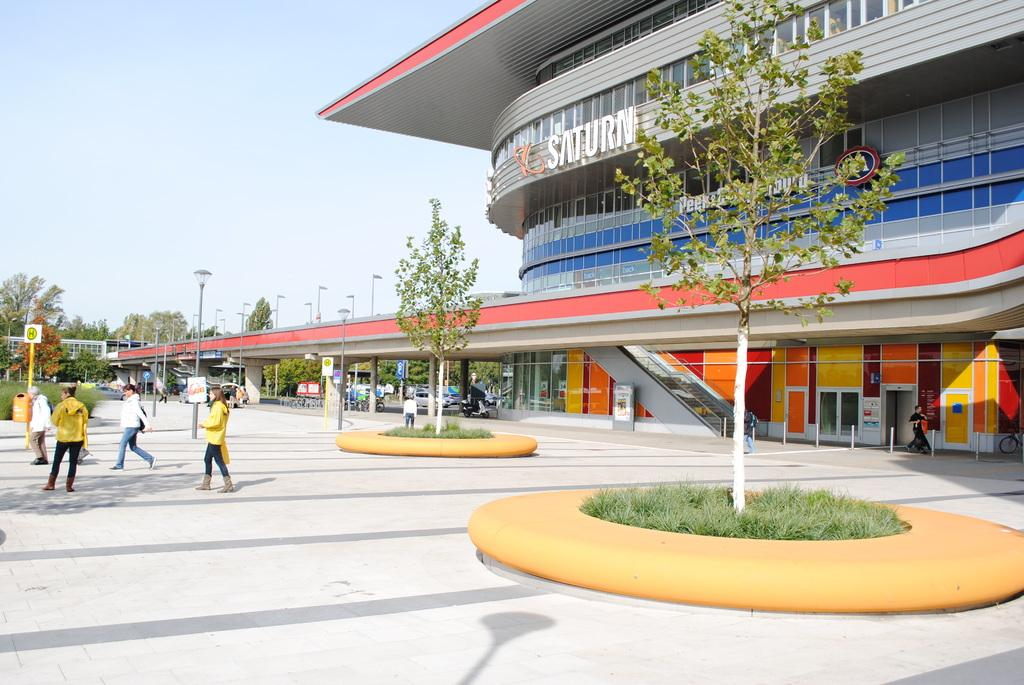<image>
Summarize the visual content of the image. A large building with red and blue stripes and the word Saturn 